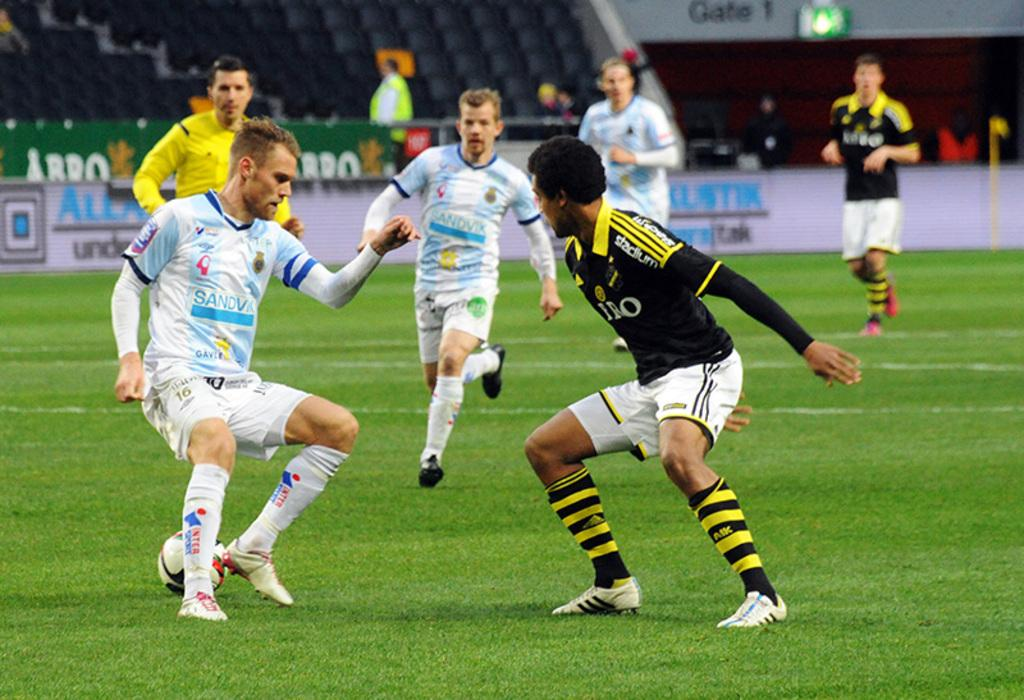What is the main object in the center of the image? There is a ball in the center of the image. What are the people in the image doing? The people in the image are running. What can be seen in the background of the image? There are chairs and banners in the background of the image. Are there any other people visible in the image? Yes, there are additional people in the background of the image. What type of cracker is being used to play chess in the image? There is no chess or cracker present in the image. What type of plough is visible in the background of the image? There is no plough visible in the image; only chairs, banners, and additional people are present in the background. 